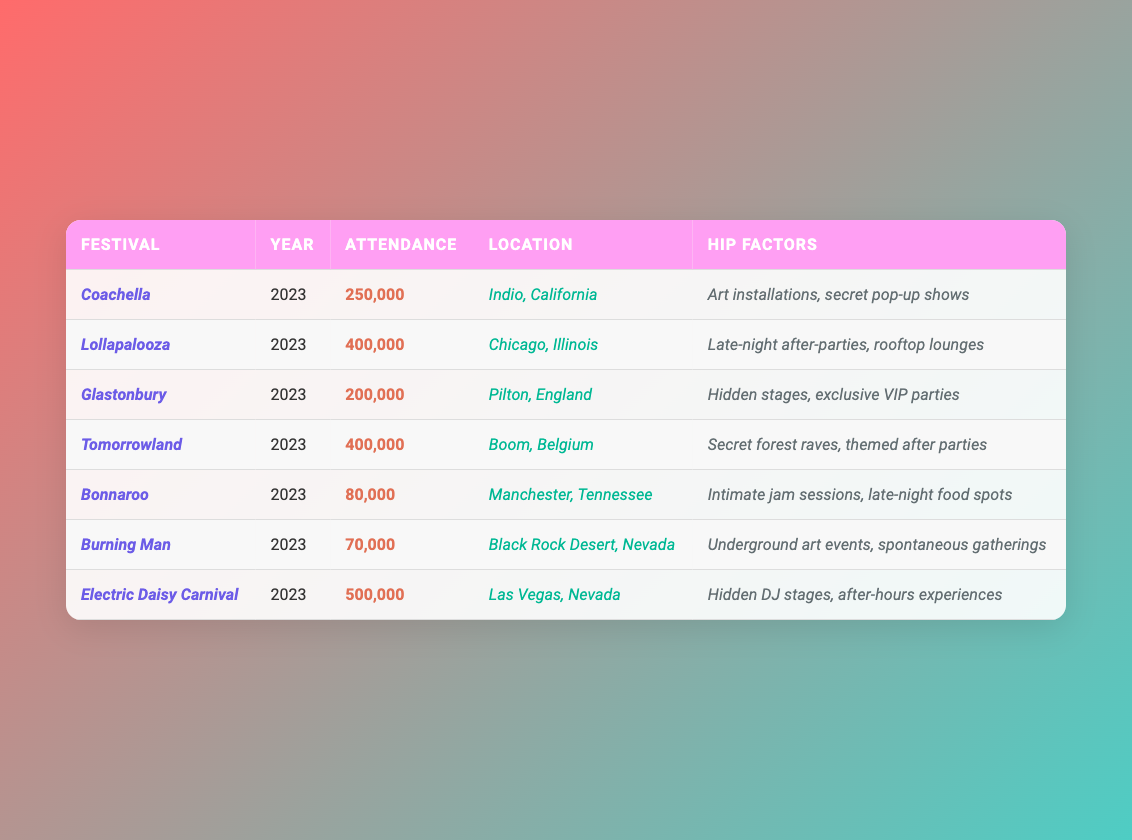What is the total attendance of all the festivals combined? To find the total attendance, add all the individual attendance figures: 250,000 + 400,000 + 200,000 + 400,000 + 80,000 + 70,000 + 500,000 = 1,900,000
Answer: 1,900,000 Which festival had the highest attendance? Looking through the attendance figures, Electric Daisy Carnival has the highest attendance at 500,000.
Answer: Electric Daisy Carnival How many festivals have an attendance of over 200,000? Review the attendance numbers: Coachella (250,000), Lollapalooza (400,000), Tomorrowland (400,000), and Electric Daisy Carnival (500,000) are all over 200,000, totaling 4 festivals.
Answer: 4 What is the average attendance of the festivals listed? To calculate the average, sum all attendances (1,900,000) and divide by the number of festivals (7): 1,900,000 / 7 = 271,428.57, which rounds to approximately 271,429.
Answer: 271,429 Which festival has the least attendance, and what is that number? Check the attendance figures: Burning Man has the least attendance of 70,000.
Answer: Burning Man, 70,000 Are there more festivals in the USA or in other countries? Festivals in the USA: Coachella, Lollapalooza, Bonnaroo, and Burning Man (4 total). Festivals outside the USA: Glastonbury, Tomorrowland, and Electric Daisy Carnival (3 total). Therefore, the USA has more festivals.
Answer: Yes, more festivals are in the USA What unique hip factor does Tomorrowland have? Tomorrowland's hip factors include secret forest raves and themed after parties, which are unique compared to others.
Answer: Secret forest raves and themed after parties If you sum the attendance of the three largest festivals, what would that total be? The three largest festivals by attendance are Electric Daisy Carnival (500,000), Lollapalooza (400,000), and Tomorrowland (400,000). Adding these gives 500,000 + 400,000 + 400,000 = 1,300,000.
Answer: 1,300,000 Which festival is located in England and what is its attendance? Glastonbury is located in England with an attendance of 200,000.
Answer: Glastonbury, 200,000 How many festivals feature after-parties as their hip factor? By checking the hip factors, Lollapalooza, Tomorrowland, and Electric Daisy Carnival all mention after-parties, totaling 3 festivals.
Answer: 3 Is there any festival with an attendance of less than 100,000? Yes, Bonnaroo (80,000) and Burning Man (70,000) both have attendances less than 100,000.
Answer: Yes 